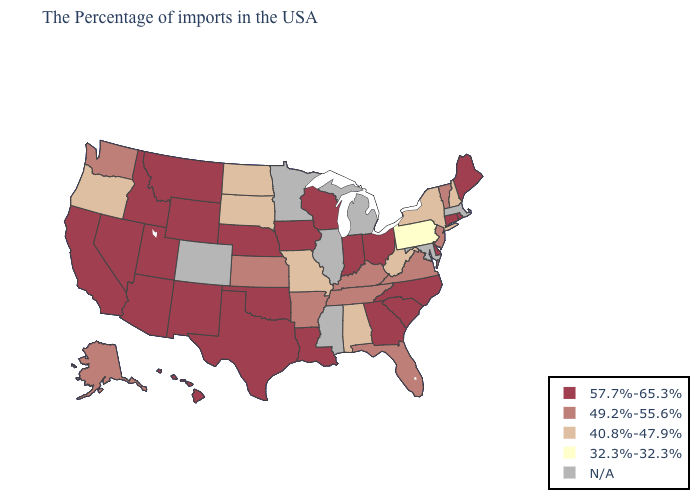What is the value of North Carolina?
Short answer required. 57.7%-65.3%. Does Arkansas have the highest value in the South?
Answer briefly. No. What is the value of Arizona?
Write a very short answer. 57.7%-65.3%. Name the states that have a value in the range N/A?
Keep it brief. Massachusetts, Maryland, Michigan, Illinois, Mississippi, Minnesota, Colorado. Does the first symbol in the legend represent the smallest category?
Short answer required. No. What is the lowest value in the USA?
Be succinct. 32.3%-32.3%. What is the lowest value in the MidWest?
Answer briefly. 40.8%-47.9%. Name the states that have a value in the range 57.7%-65.3%?
Quick response, please. Maine, Rhode Island, Connecticut, Delaware, North Carolina, South Carolina, Ohio, Georgia, Indiana, Wisconsin, Louisiana, Iowa, Nebraska, Oklahoma, Texas, Wyoming, New Mexico, Utah, Montana, Arizona, Idaho, Nevada, California, Hawaii. Name the states that have a value in the range N/A?
Write a very short answer. Massachusetts, Maryland, Michigan, Illinois, Mississippi, Minnesota, Colorado. Does Texas have the highest value in the USA?
Concise answer only. Yes. Does Pennsylvania have the lowest value in the USA?
Keep it brief. Yes. Name the states that have a value in the range 49.2%-55.6%?
Write a very short answer. Vermont, New Jersey, Virginia, Florida, Kentucky, Tennessee, Arkansas, Kansas, Washington, Alaska. 